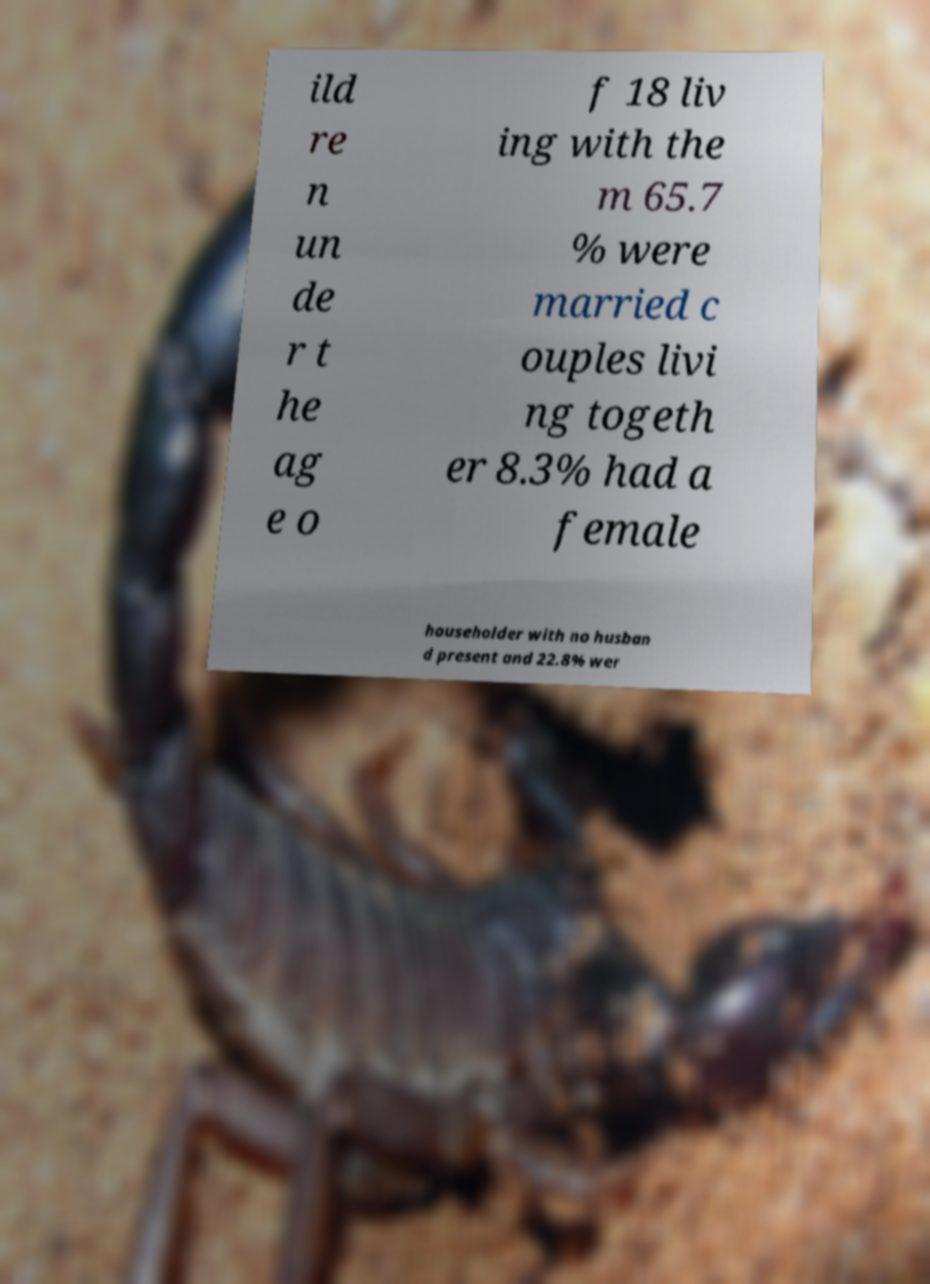Could you extract and type out the text from this image? ild re n un de r t he ag e o f 18 liv ing with the m 65.7 % were married c ouples livi ng togeth er 8.3% had a female householder with no husban d present and 22.8% wer 